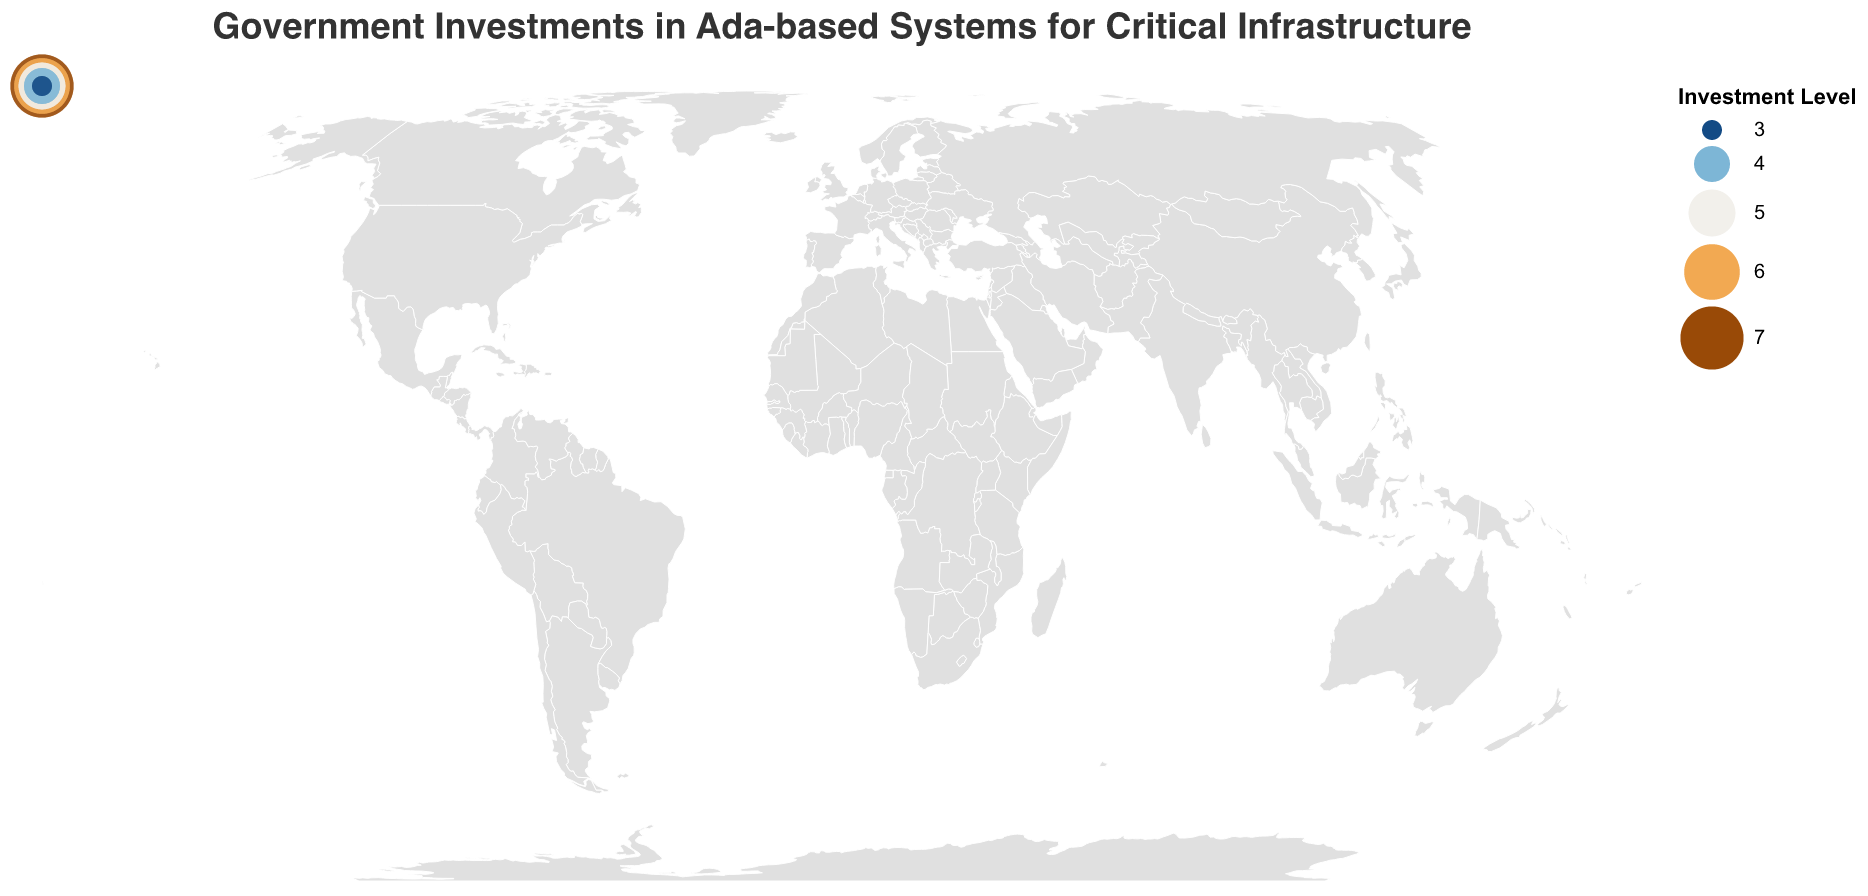Which countries have the highest investment level in Ada-based systems? The countries with the highest investment level in Ada-based systems are those marked with the largest and most prominently colored data points. By inspecting the figure, the countries with an investment level of 7 are Canada and the United Kingdom.
Answer: Canada, United Kingdom What types of Ada-based critical infrastructure projects are present in countries with an investment level of 6? The countries with an investment level of 6 can be identified by their size and color. According to the data, Germany and Sweden both fall into this category. Germany has public transportation systems, and Sweden has automotive safety systems as their Ada-based projects.
Answer: Public transportation systems (Germany), Automotive safety systems (Sweden) Which country focuses on offshore oil platform control using Ada, and what is its investment level? By identifying the country related to offshore oil platform control in the figure, we find Norway. The investment level for Norway can be seen through the size and color of the data point representing it, which is 3.
Answer: Norway, 3 How do the investment levels in Ada-based systems for Canada and India compare? We can compare the sizes and colors of data points representing Canada and India. Canada has an investment level of 7, while India has an investment level of 5. Thus, Canada has a higher investment level than India.
Answer: Canada > India What is the average investment level of the countries listed in the data? To compute the average investment level, sum all the investment levels and divide by the number of countries. The sum is 7 + 7 + 6 + 6 + 5 + 5 + 4 + 4 + 3 + 3 = 50. There are 10 countries, so the average investment level is 50/10.
Answer: 5 What types of projects are being carried out in countries with a relatively low investment level (investment level of 4 or lower)? By identifying the countries with investment levels of 4 or lower, we see that Japan and Brazil have an investment level of 4, and Norway and Finland have an investment level of 3. Their respective projects are industrial automation (Japan), energy grid management (Brazil), offshore oil platform control (Norway), and medical device software (Finland).
Answer: Industrial automation (Japan), Energy grid management (Brazil), Offshore oil platform control (Norway), Medical device software (Finland) Between Germany and Australia, which country has a higher investment level in Ada-based systems, and by how much? By inspecting the sizes and colors of the data points for Germany and Australia, we see that Germany has an investment level of 6, while Australia has an investment level of 5. The difference in investment levels is 6 - 5.
Answer: Germany, by 1 What is the primary type of Ada-based project in Sweden, and what is its investment level? By looking at the figure, the type of Ada-based project in Sweden is identified as automotive safety systems, and the investment level, represented by the data point's size and color, is 6.
Answer: Automotive safety systems, 6 Which countries have an investment level of 5, and what Ada-based projects are they focusing on? The countries with an investment level of 5 can be determined by examining the data and visual representation. These countries are Australia and India, focusing on maritime navigation systems (Australia) and space program control systems (India) respectively.
Answer: Australia (Maritime navigation systems), India (Space program control systems) 